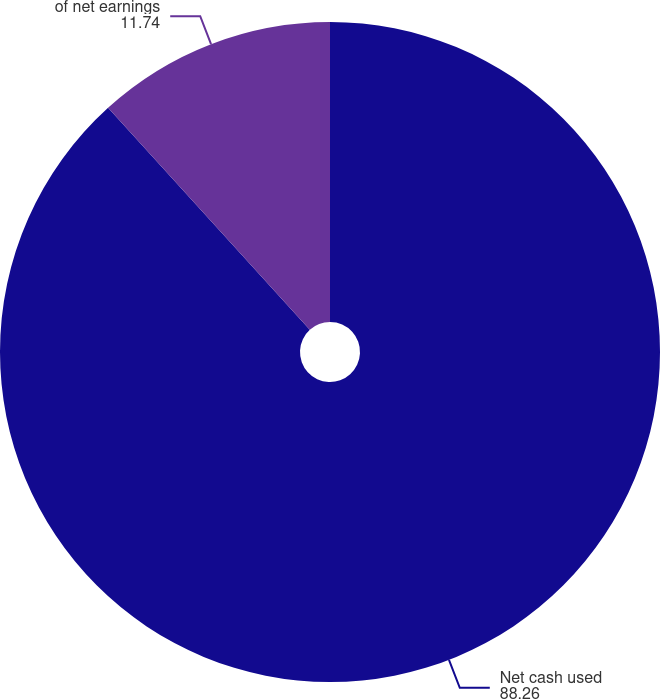Convert chart. <chart><loc_0><loc_0><loc_500><loc_500><pie_chart><fcel>Net cash used<fcel>of net earnings<nl><fcel>88.26%<fcel>11.74%<nl></chart> 